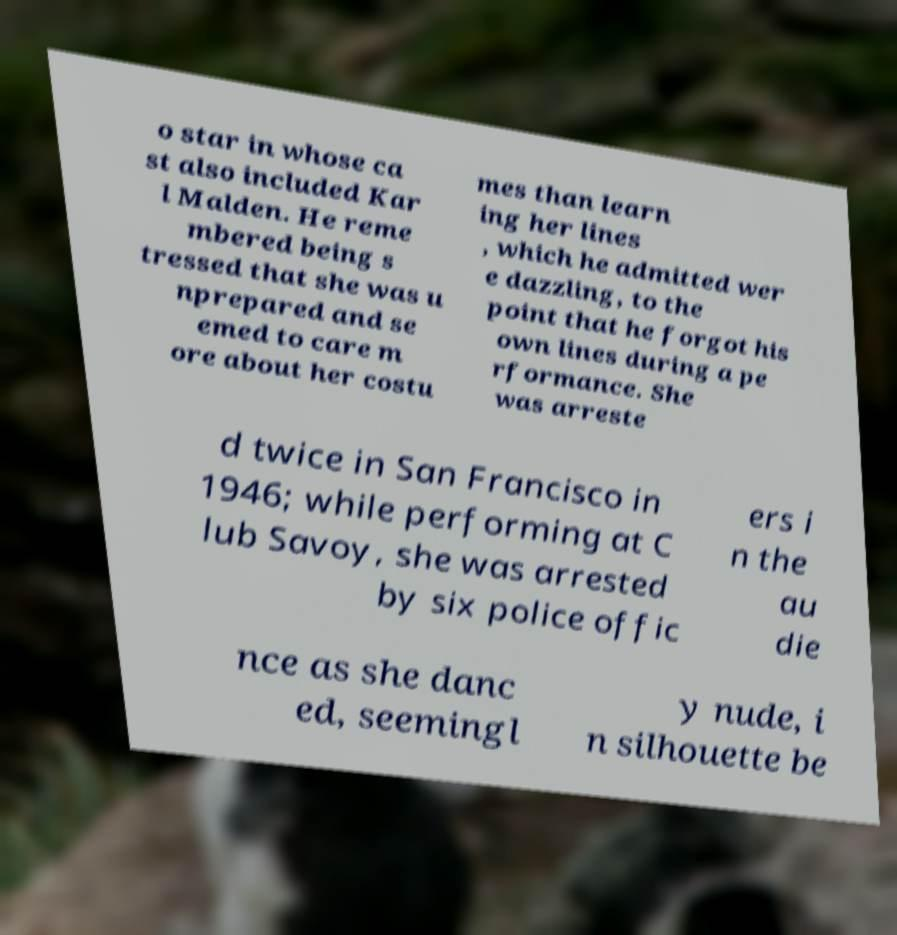I need the written content from this picture converted into text. Can you do that? o star in whose ca st also included Kar l Malden. He reme mbered being s tressed that she was u nprepared and se emed to care m ore about her costu mes than learn ing her lines , which he admitted wer e dazzling, to the point that he forgot his own lines during a pe rformance. She was arreste d twice in San Francisco in 1946; while performing at C lub Savoy, she was arrested by six police offic ers i n the au die nce as she danc ed, seemingl y nude, i n silhouette be 